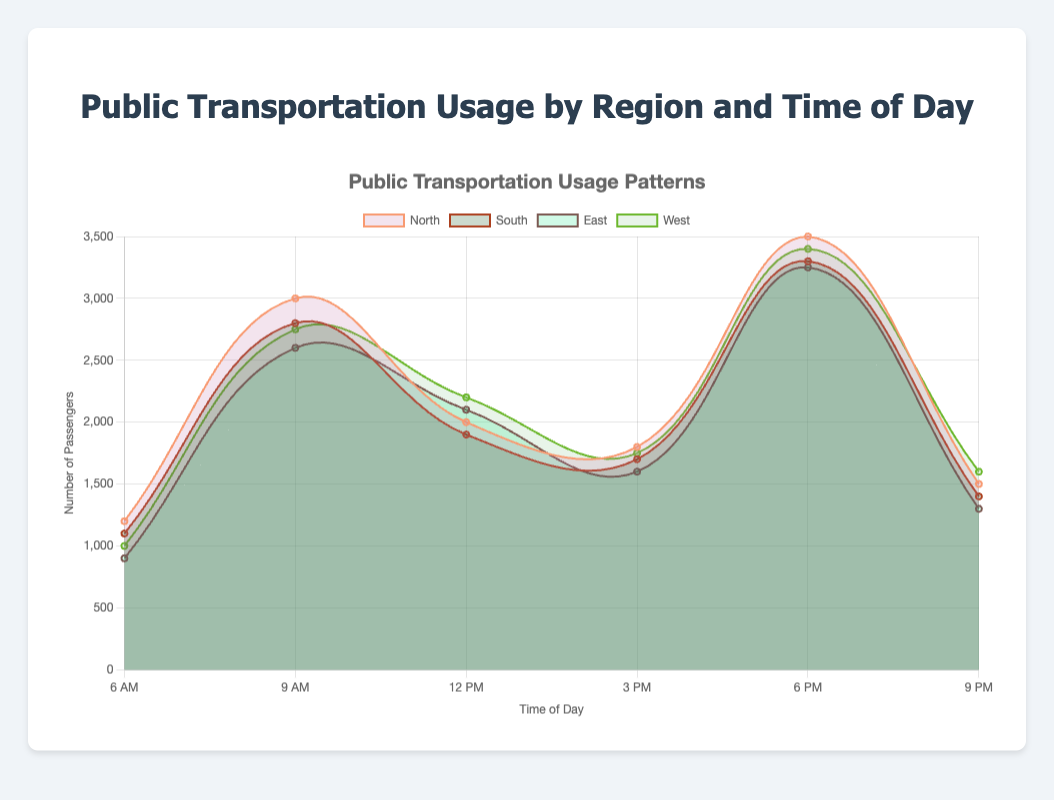What is the title of the chart? The title of the chart is provided at the top and it states "Public Transportation Usage by Region and Time of Day".
Answer: Public Transportation Usage by Region and Time of Day How many regions are represented in this chart? The chart displays data for four different regions, which are indicated by the different colors and labels in the legend.
Answer: Four At what time of the day does the North region have the highest number of passengers? By examining the data points for the North region, the highest number of passengers occurs at 6 PM with 3500 passengers.
Answer: 6 PM Which region has the least number of passengers at 9 PM? By looking at the data points for 9 PM across all regions, the East region has the least number of passengers with 1300 passengers.
Answer: East What trend is observed in the passenger count for the South region throughout the day? The passenger count in the South region increases from 6 AM (1100 passengers) to a peak at 6 PM (3300 passengers), then decreases by 9 PM (1400 passengers).
Answer: Increase to a peak at 6 PM, then decreases What is the combined number of passengers for the East region at 9 AM and 12 PM? The number of passengers for the East region at 9 AM is 2600 and at 12 PM is 2100. Adding these together gives 2600 + 2100 = 4700.
Answer: 4700 Which region experiences the highest peak in passenger count, and at what time does it occur? The North region has the highest peak in passenger count at 6 PM with 3500 passengers.
Answer: North at 6 PM Compare the passenger count trends between the East and West regions from 6 AM to 3 PM. From 6 AM to 3 PM, the East region starts lower (900) and trends upwards to 1600. The West region starts slightly higher (1000) and also trends upwards to 1750, but both show similar upward trends with East slightly trailing West.
Answer: Both trend upwards, East starts lower What can you conclude about public transportation usage patterns by time of day across all regions? Generally, passenger counts in all regions peak during morning (9 AM) and evening (6 PM) rush hours, indicating higher usage during these times.
Answer: Peaks during 9 AM and 6 PM Which region shows the smallest change in passenger count throughout the day? By comparing the ranges of the passenger counts, the South region shows a consistent pattern but with relatively smaller changes in passenger count, specifically between 6 AM (1100) and 9 PM (1400).
Answer: South 